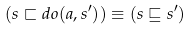<formula> <loc_0><loc_0><loc_500><loc_500>( s \sqsubset d o ( a , s ^ { \prime } ) ) \equiv ( s \sqsubseteq s ^ { \prime } )</formula> 